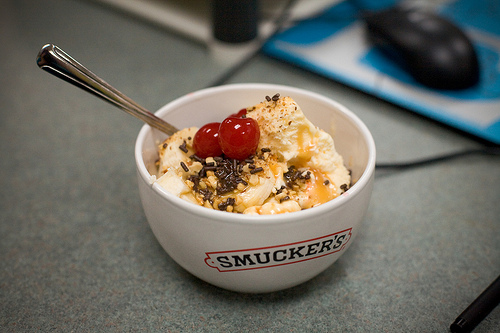<image>
Is there a spoon next to the bowl? No. The spoon is not positioned next to the bowl. They are located in different areas of the scene. Is the cup in front of the mouse? Yes. The cup is positioned in front of the mouse, appearing closer to the camera viewpoint. 